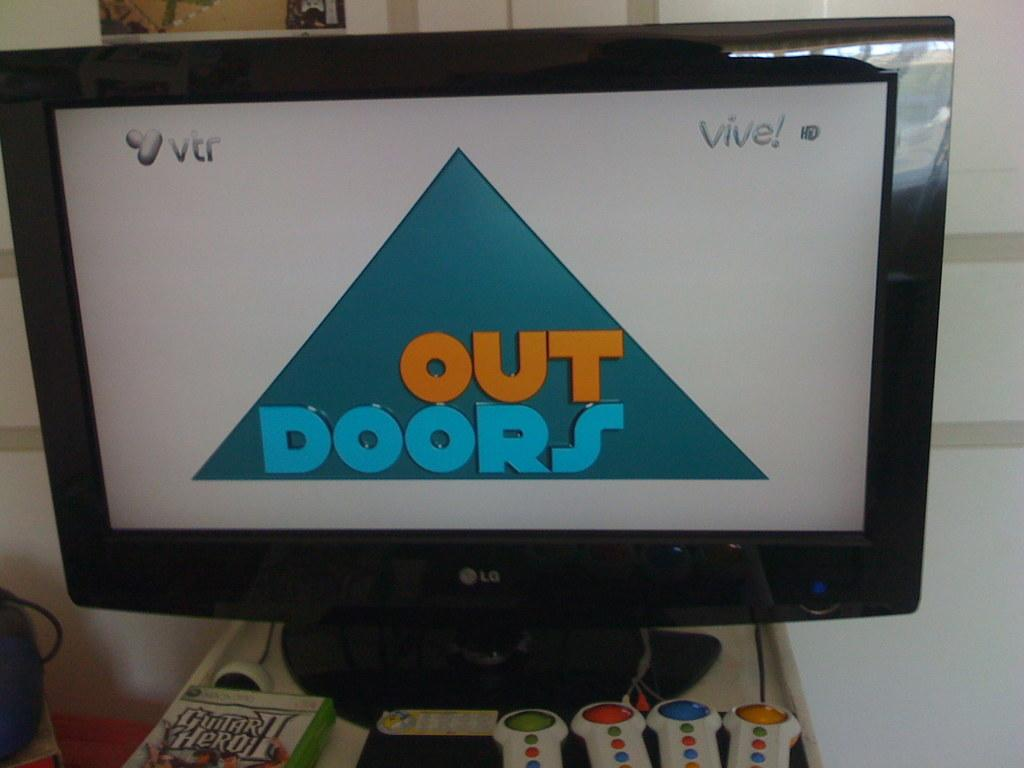<image>
Share a concise interpretation of the image provided. A computer monitor has an OUTDOORS logo displayed on it. 